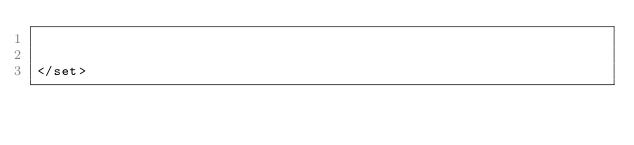Convert code to text. <code><loc_0><loc_0><loc_500><loc_500><_XML_>

</set></code> 